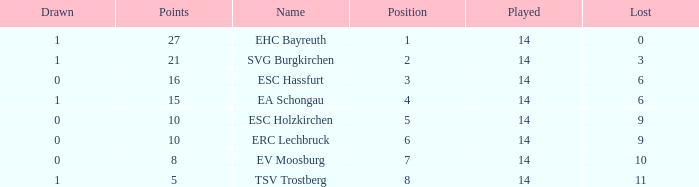What's the points that has a lost more 6, played less than 14 and a position more than 1? None. 